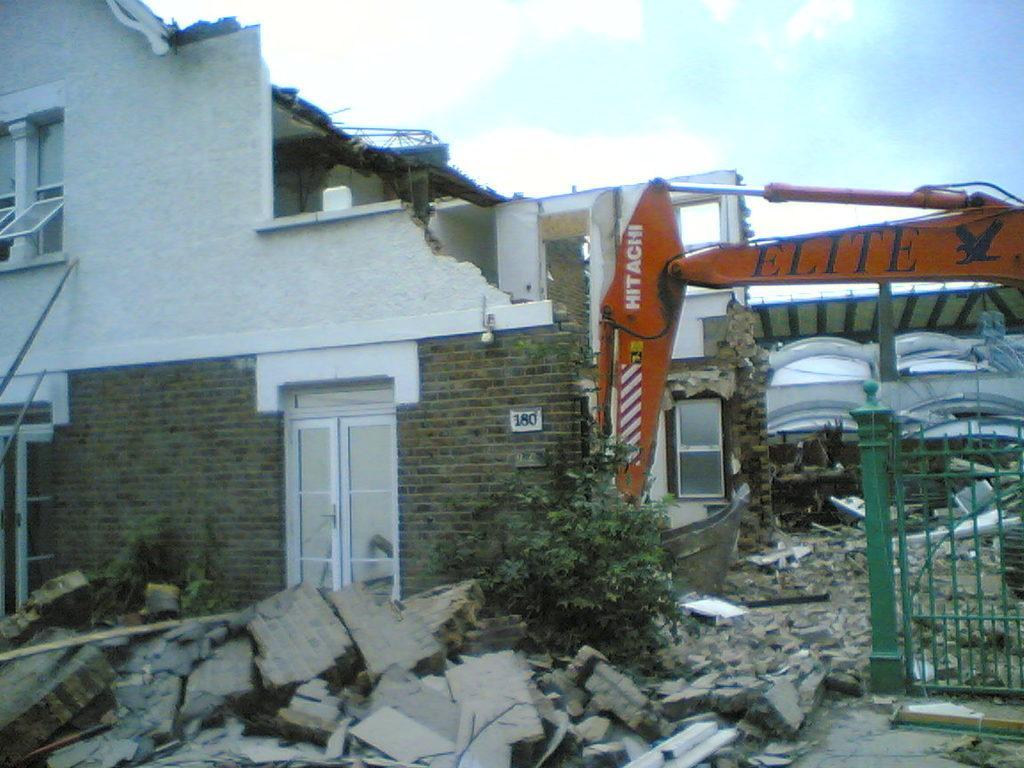How would you summarize this image in a sentence or two? Here in this picture we can see a house being collapsed by a crane present over there and we can see windows on the house and we can see plants and gate also present over there and we can see clouds in sky. 